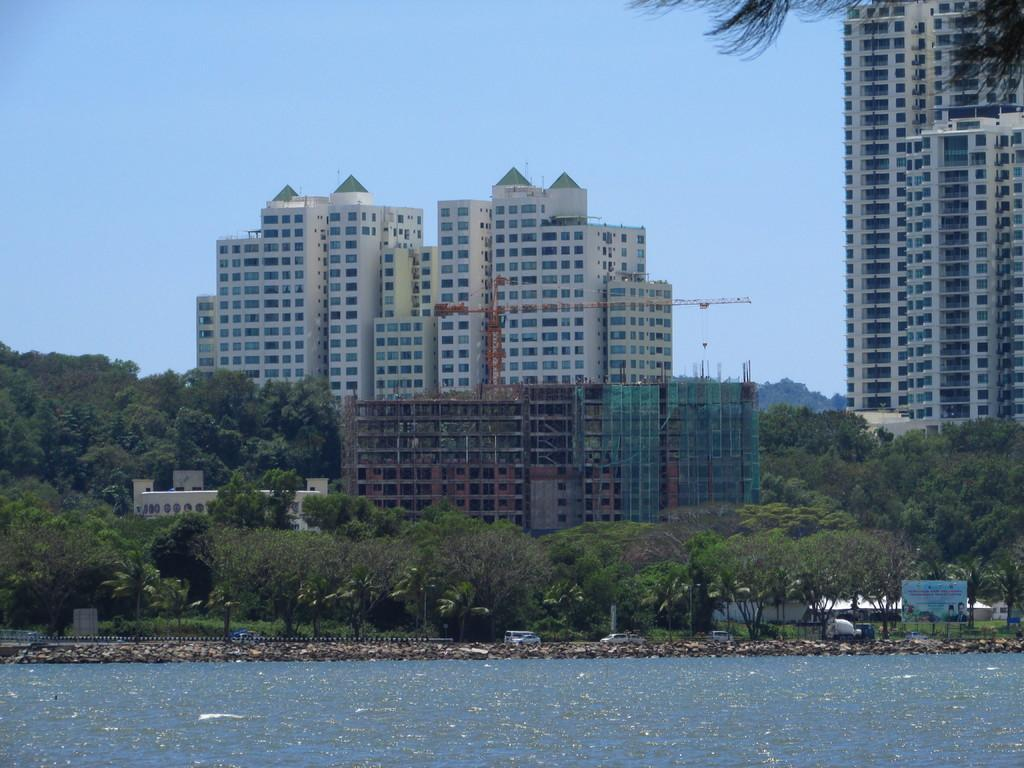What type of natural elements can be seen in the image? There are trees in the image. What type of man-made structures are present in the image? There are buildings in the image. What is the lowest visible surface in the image? There is a water surface at the bottom of the image. What is visible at the top of the image? The sky is visible at the top of the image. What type of design can be seen on the chicken in the image? There are no chickens present in the image; it features trees, buildings, a water surface, and the sky. 